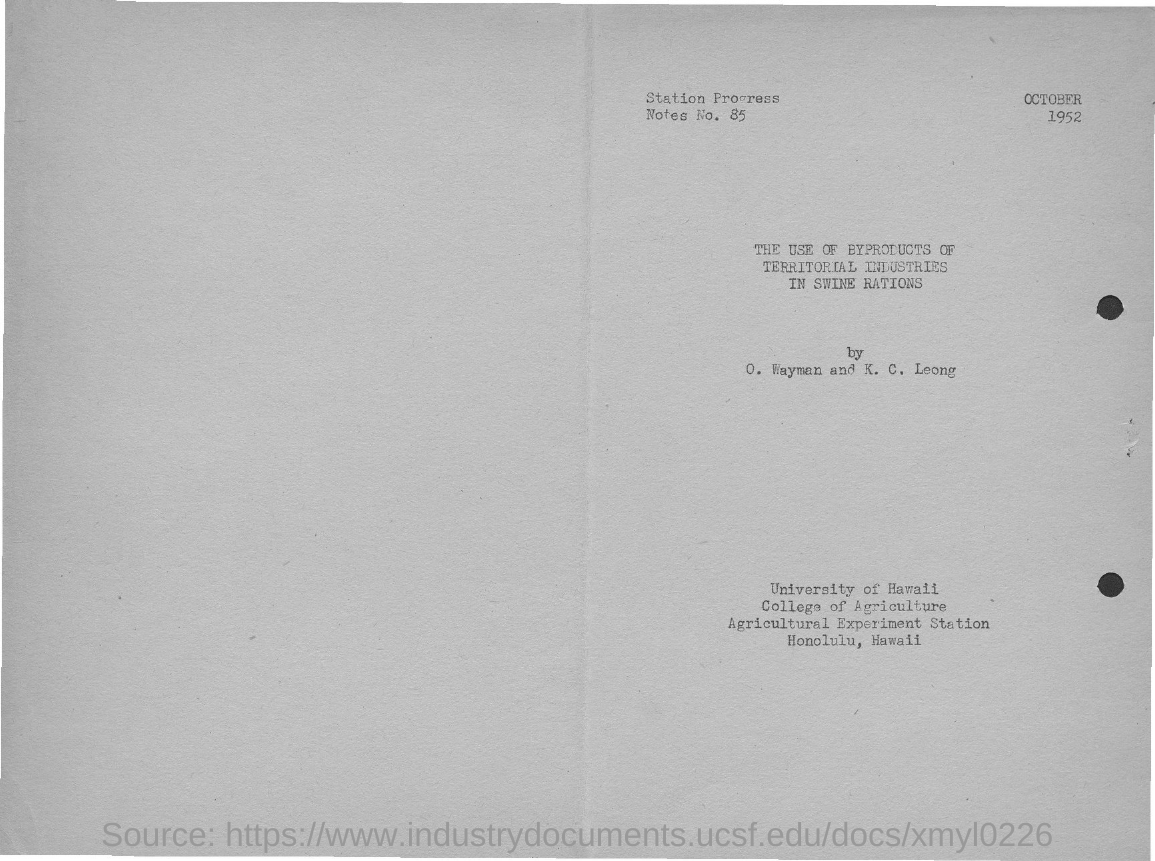What is the number of station progress notes?
Your answer should be very brief. 85. What is the date mentioned in the document?
Provide a short and direct response. OCTOBER 1952. 